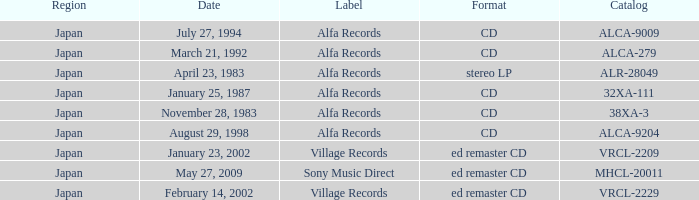Parse the table in full. {'header': ['Region', 'Date', 'Label', 'Format', 'Catalog'], 'rows': [['Japan', 'July 27, 1994', 'Alfa Records', 'CD', 'ALCA-9009'], ['Japan', 'March 21, 1992', 'Alfa Records', 'CD', 'ALCA-279'], ['Japan', 'April 23, 1983', 'Alfa Records', 'stereo LP', 'ALR-28049'], ['Japan', 'January 25, 1987', 'Alfa Records', 'CD', '32XA-111'], ['Japan', 'November 28, 1983', 'Alfa Records', 'CD', '38XA-3'], ['Japan', 'August 29, 1998', 'Alfa Records', 'CD', 'ALCA-9204'], ['Japan', 'January 23, 2002', 'Village Records', 'ed remaster CD', 'VRCL-2209'], ['Japan', 'May 27, 2009', 'Sony Music Direct', 'ed remaster CD', 'MHCL-20011'], ['Japan', 'February 14, 2002', 'Village Records', 'ed remaster CD', 'VRCL-2229']]} What is the format of the date February 14, 2002? Ed remaster cd. 